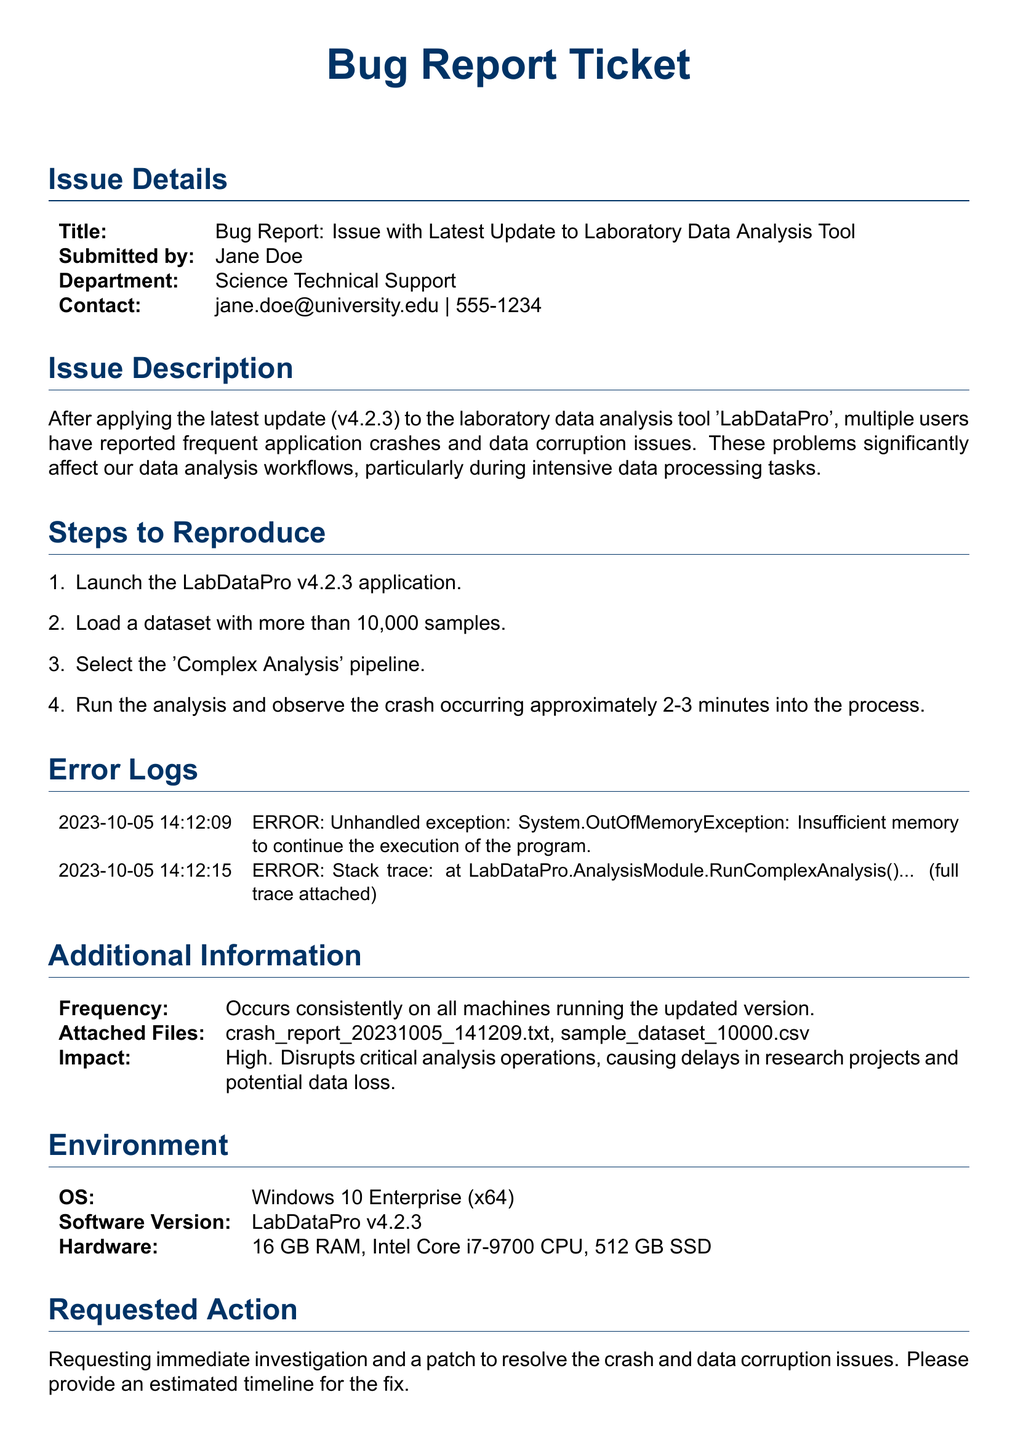What is the title of the bug report? The title of the bug report is specified in the document's issue details section.
Answer: Bug Report: Issue with Latest Update to Laboratory Data Analysis Tool Who submitted the bug report? The document clearly states the person who submitted the bug report in the issue details.
Answer: Jane Doe What is the submitted version of the software? The version of the software under discussion is mentioned in the issue description section.
Answer: v4.2.3 What type of exception is mentioned in the error logs? The error logs indicate the type of exception encountered by the application.
Answer: System.OutOfMemoryException What frequency is reported for the application crashes? The document provides a frequency report in the additional information section.
Answer: Occurs consistently on all machines What is the impact of the bugs reported? The impact of the bugs is addressed in the additional information section.
Answer: High What operating system is the LabDataPro run on? The operating system is specified in the environment section of the document.
Answer: Windows 10 Enterprise (x64) What is requested at the end of the document? The conclusion of the document states a request related to the bug report.
Answer: Immediate investigation and a patch What is the hardware specification listed in the environment section? The hardware is outlined in the environment section, noting specific components.
Answer: 16 GB RAM, Intel Core i7-9700 CPU, 512 GB SSD 